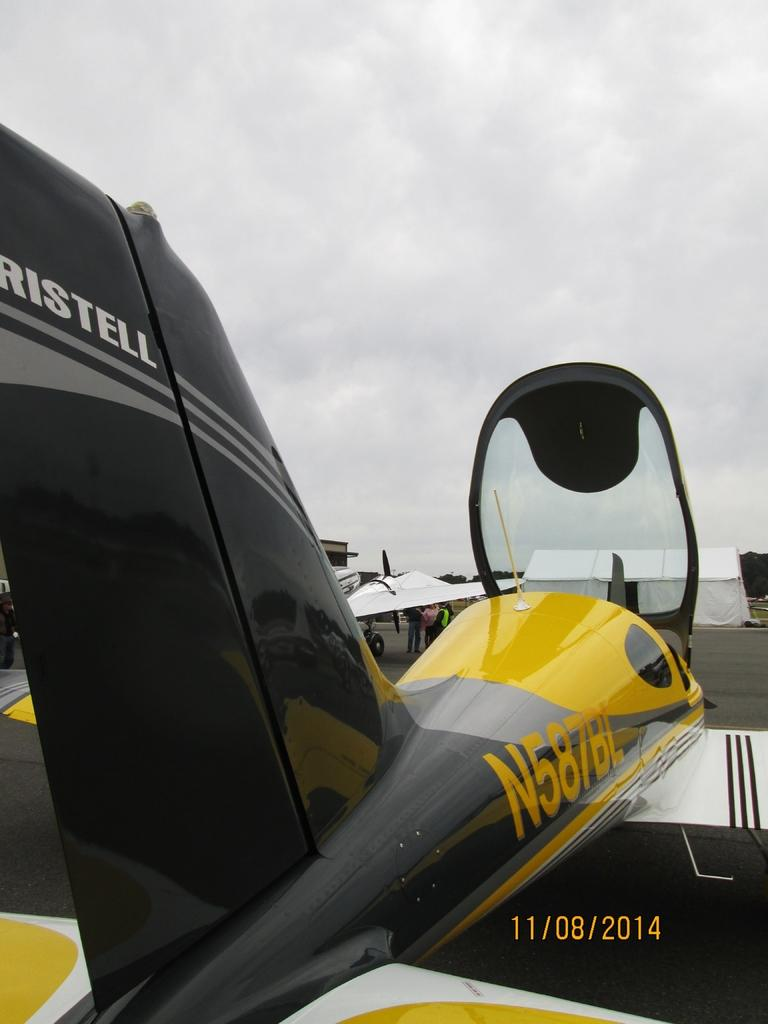What can be seen on the runway in the image? There are aeroplanes on the runway in the image. What structure is located in front of the aeroplanes? There is a white tent in front of the aeroplanes. What are some people doing in the image? Some people are standing under the wing of an aeroplane. Can you see any cherries on the aeroplanes in the image? There are no cherries present on the aeroplanes in the image. What sound can be heard coming from the baby in the image? There is no baby present in the image, so no sound can be heard. 